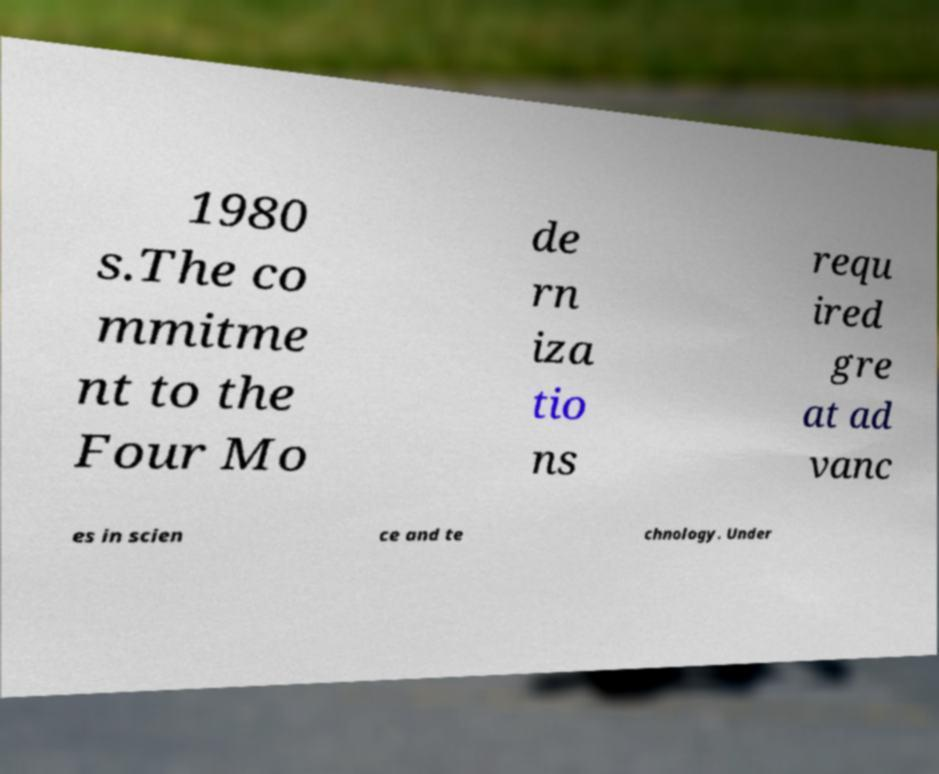I need the written content from this picture converted into text. Can you do that? 1980 s.The co mmitme nt to the Four Mo de rn iza tio ns requ ired gre at ad vanc es in scien ce and te chnology. Under 